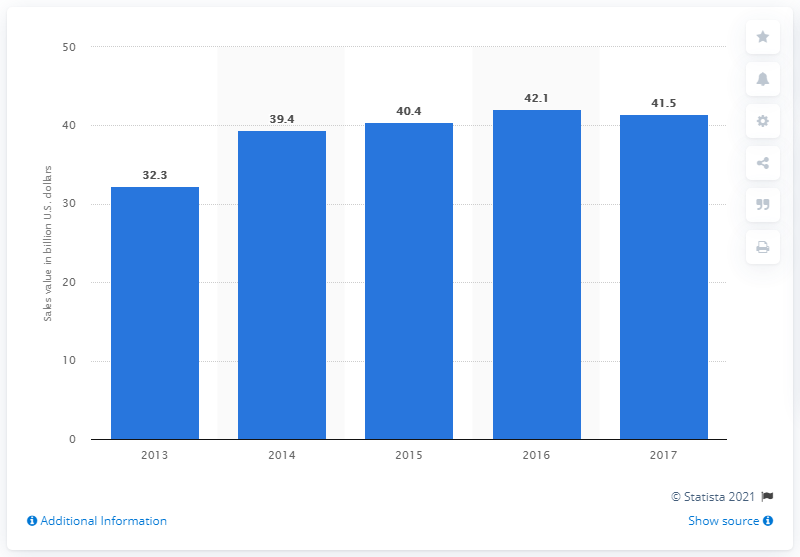Mention a couple of crucial points in this snapshot. In 2017, the revenue from smartphone sales in the Middle East and Africa was 41.5 billion U.S. dollars. 